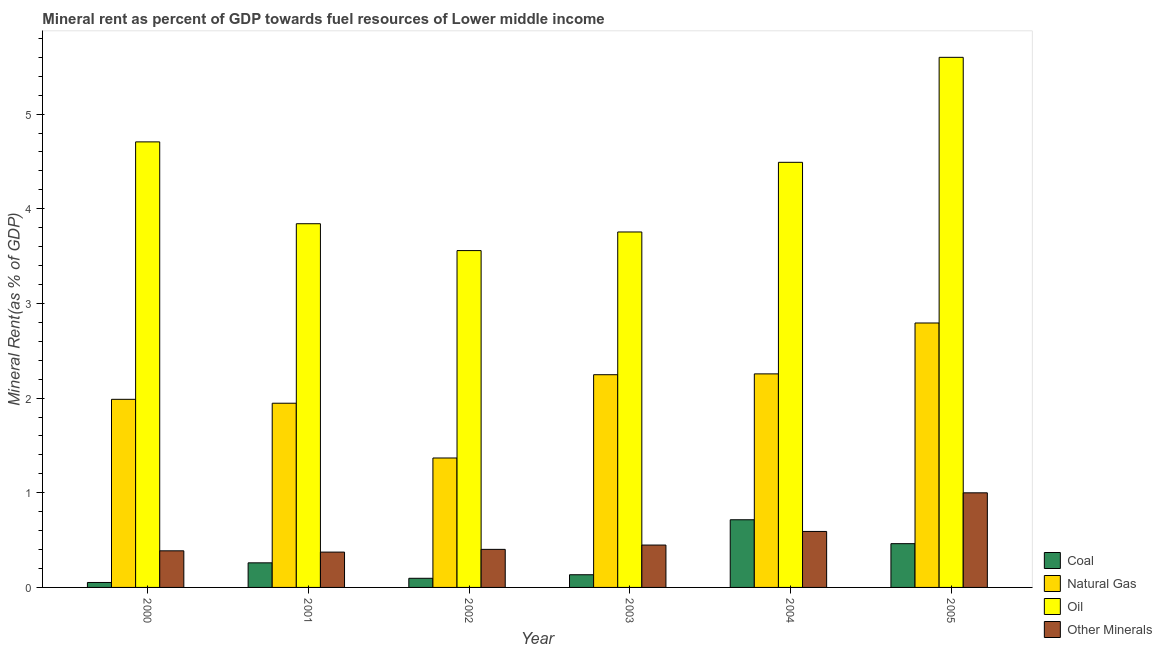Are the number of bars per tick equal to the number of legend labels?
Your answer should be compact. Yes. How many bars are there on the 5th tick from the left?
Ensure brevity in your answer.  4. How many bars are there on the 4th tick from the right?
Give a very brief answer. 4. What is the label of the 6th group of bars from the left?
Your response must be concise. 2005. In how many cases, is the number of bars for a given year not equal to the number of legend labels?
Make the answer very short. 0. What is the coal rent in 2001?
Make the answer very short. 0.26. Across all years, what is the maximum coal rent?
Your answer should be compact. 0.71. Across all years, what is the minimum  rent of other minerals?
Ensure brevity in your answer.  0.37. In which year was the coal rent maximum?
Ensure brevity in your answer.  2004. In which year was the coal rent minimum?
Your answer should be compact. 2000. What is the total  rent of other minerals in the graph?
Your response must be concise. 3.2. What is the difference between the  rent of other minerals in 2002 and that in 2004?
Provide a succinct answer. -0.19. What is the difference between the natural gas rent in 2005 and the oil rent in 2003?
Give a very brief answer. 0.55. What is the average natural gas rent per year?
Give a very brief answer. 2.1. In the year 2004, what is the difference between the natural gas rent and coal rent?
Give a very brief answer. 0. What is the ratio of the coal rent in 2000 to that in 2002?
Offer a terse response. 0.54. What is the difference between the highest and the second highest  rent of other minerals?
Make the answer very short. 0.41. What is the difference between the highest and the lowest natural gas rent?
Keep it short and to the point. 1.43. In how many years, is the coal rent greater than the average coal rent taken over all years?
Your response must be concise. 2. What does the 1st bar from the left in 2001 represents?
Offer a terse response. Coal. What does the 4th bar from the right in 2000 represents?
Keep it short and to the point. Coal. Are all the bars in the graph horizontal?
Provide a succinct answer. No. How many years are there in the graph?
Keep it short and to the point. 6. What is the difference between two consecutive major ticks on the Y-axis?
Your answer should be very brief. 1. Are the values on the major ticks of Y-axis written in scientific E-notation?
Offer a terse response. No. Does the graph contain any zero values?
Provide a short and direct response. No. How many legend labels are there?
Provide a short and direct response. 4. What is the title of the graph?
Your answer should be very brief. Mineral rent as percent of GDP towards fuel resources of Lower middle income. Does "UNTA" appear as one of the legend labels in the graph?
Provide a succinct answer. No. What is the label or title of the X-axis?
Make the answer very short. Year. What is the label or title of the Y-axis?
Provide a short and direct response. Mineral Rent(as % of GDP). What is the Mineral Rent(as % of GDP) of Coal in 2000?
Provide a short and direct response. 0.05. What is the Mineral Rent(as % of GDP) in Natural Gas in 2000?
Your answer should be compact. 1.99. What is the Mineral Rent(as % of GDP) of Oil in 2000?
Offer a very short reply. 4.71. What is the Mineral Rent(as % of GDP) in Other Minerals in 2000?
Make the answer very short. 0.39. What is the Mineral Rent(as % of GDP) of Coal in 2001?
Provide a succinct answer. 0.26. What is the Mineral Rent(as % of GDP) in Natural Gas in 2001?
Ensure brevity in your answer.  1.95. What is the Mineral Rent(as % of GDP) of Oil in 2001?
Offer a very short reply. 3.84. What is the Mineral Rent(as % of GDP) in Other Minerals in 2001?
Offer a terse response. 0.37. What is the Mineral Rent(as % of GDP) in Coal in 2002?
Your response must be concise. 0.1. What is the Mineral Rent(as % of GDP) in Natural Gas in 2002?
Provide a succinct answer. 1.37. What is the Mineral Rent(as % of GDP) of Oil in 2002?
Keep it short and to the point. 3.56. What is the Mineral Rent(as % of GDP) in Other Minerals in 2002?
Make the answer very short. 0.4. What is the Mineral Rent(as % of GDP) of Coal in 2003?
Give a very brief answer. 0.13. What is the Mineral Rent(as % of GDP) in Natural Gas in 2003?
Your answer should be compact. 2.25. What is the Mineral Rent(as % of GDP) of Oil in 2003?
Make the answer very short. 3.75. What is the Mineral Rent(as % of GDP) of Other Minerals in 2003?
Give a very brief answer. 0.45. What is the Mineral Rent(as % of GDP) of Coal in 2004?
Provide a short and direct response. 0.71. What is the Mineral Rent(as % of GDP) of Natural Gas in 2004?
Provide a short and direct response. 2.26. What is the Mineral Rent(as % of GDP) of Oil in 2004?
Your response must be concise. 4.49. What is the Mineral Rent(as % of GDP) in Other Minerals in 2004?
Keep it short and to the point. 0.59. What is the Mineral Rent(as % of GDP) in Coal in 2005?
Your answer should be compact. 0.46. What is the Mineral Rent(as % of GDP) of Natural Gas in 2005?
Give a very brief answer. 2.79. What is the Mineral Rent(as % of GDP) in Oil in 2005?
Your answer should be very brief. 5.6. What is the Mineral Rent(as % of GDP) in Other Minerals in 2005?
Give a very brief answer. 1. Across all years, what is the maximum Mineral Rent(as % of GDP) of Coal?
Your answer should be compact. 0.71. Across all years, what is the maximum Mineral Rent(as % of GDP) of Natural Gas?
Your response must be concise. 2.79. Across all years, what is the maximum Mineral Rent(as % of GDP) of Oil?
Your answer should be compact. 5.6. Across all years, what is the maximum Mineral Rent(as % of GDP) in Other Minerals?
Offer a very short reply. 1. Across all years, what is the minimum Mineral Rent(as % of GDP) of Coal?
Your answer should be compact. 0.05. Across all years, what is the minimum Mineral Rent(as % of GDP) in Natural Gas?
Make the answer very short. 1.37. Across all years, what is the minimum Mineral Rent(as % of GDP) in Oil?
Offer a very short reply. 3.56. Across all years, what is the minimum Mineral Rent(as % of GDP) of Other Minerals?
Your answer should be compact. 0.37. What is the total Mineral Rent(as % of GDP) of Coal in the graph?
Provide a succinct answer. 1.72. What is the total Mineral Rent(as % of GDP) in Natural Gas in the graph?
Provide a short and direct response. 12.6. What is the total Mineral Rent(as % of GDP) of Oil in the graph?
Make the answer very short. 25.95. What is the total Mineral Rent(as % of GDP) of Other Minerals in the graph?
Ensure brevity in your answer.  3.2. What is the difference between the Mineral Rent(as % of GDP) in Coal in 2000 and that in 2001?
Your answer should be very brief. -0.21. What is the difference between the Mineral Rent(as % of GDP) of Natural Gas in 2000 and that in 2001?
Your answer should be compact. 0.04. What is the difference between the Mineral Rent(as % of GDP) in Oil in 2000 and that in 2001?
Your answer should be compact. 0.86. What is the difference between the Mineral Rent(as % of GDP) in Other Minerals in 2000 and that in 2001?
Your answer should be compact. 0.01. What is the difference between the Mineral Rent(as % of GDP) in Coal in 2000 and that in 2002?
Keep it short and to the point. -0.04. What is the difference between the Mineral Rent(as % of GDP) of Natural Gas in 2000 and that in 2002?
Ensure brevity in your answer.  0.62. What is the difference between the Mineral Rent(as % of GDP) of Oil in 2000 and that in 2002?
Provide a succinct answer. 1.15. What is the difference between the Mineral Rent(as % of GDP) in Other Minerals in 2000 and that in 2002?
Give a very brief answer. -0.02. What is the difference between the Mineral Rent(as % of GDP) in Coal in 2000 and that in 2003?
Your response must be concise. -0.08. What is the difference between the Mineral Rent(as % of GDP) in Natural Gas in 2000 and that in 2003?
Your answer should be very brief. -0.26. What is the difference between the Mineral Rent(as % of GDP) in Oil in 2000 and that in 2003?
Keep it short and to the point. 0.95. What is the difference between the Mineral Rent(as % of GDP) in Other Minerals in 2000 and that in 2003?
Ensure brevity in your answer.  -0.06. What is the difference between the Mineral Rent(as % of GDP) of Coal in 2000 and that in 2004?
Keep it short and to the point. -0.66. What is the difference between the Mineral Rent(as % of GDP) in Natural Gas in 2000 and that in 2004?
Your response must be concise. -0.27. What is the difference between the Mineral Rent(as % of GDP) in Oil in 2000 and that in 2004?
Offer a terse response. 0.22. What is the difference between the Mineral Rent(as % of GDP) of Other Minerals in 2000 and that in 2004?
Your answer should be compact. -0.2. What is the difference between the Mineral Rent(as % of GDP) of Coal in 2000 and that in 2005?
Your answer should be very brief. -0.41. What is the difference between the Mineral Rent(as % of GDP) of Natural Gas in 2000 and that in 2005?
Give a very brief answer. -0.81. What is the difference between the Mineral Rent(as % of GDP) of Oil in 2000 and that in 2005?
Offer a very short reply. -0.89. What is the difference between the Mineral Rent(as % of GDP) in Other Minerals in 2000 and that in 2005?
Offer a very short reply. -0.61. What is the difference between the Mineral Rent(as % of GDP) of Coal in 2001 and that in 2002?
Ensure brevity in your answer.  0.16. What is the difference between the Mineral Rent(as % of GDP) in Natural Gas in 2001 and that in 2002?
Make the answer very short. 0.58. What is the difference between the Mineral Rent(as % of GDP) in Oil in 2001 and that in 2002?
Keep it short and to the point. 0.28. What is the difference between the Mineral Rent(as % of GDP) of Other Minerals in 2001 and that in 2002?
Keep it short and to the point. -0.03. What is the difference between the Mineral Rent(as % of GDP) of Coal in 2001 and that in 2003?
Provide a succinct answer. 0.13. What is the difference between the Mineral Rent(as % of GDP) of Natural Gas in 2001 and that in 2003?
Your answer should be very brief. -0.3. What is the difference between the Mineral Rent(as % of GDP) in Oil in 2001 and that in 2003?
Give a very brief answer. 0.09. What is the difference between the Mineral Rent(as % of GDP) in Other Minerals in 2001 and that in 2003?
Provide a succinct answer. -0.07. What is the difference between the Mineral Rent(as % of GDP) in Coal in 2001 and that in 2004?
Ensure brevity in your answer.  -0.46. What is the difference between the Mineral Rent(as % of GDP) in Natural Gas in 2001 and that in 2004?
Ensure brevity in your answer.  -0.31. What is the difference between the Mineral Rent(as % of GDP) of Oil in 2001 and that in 2004?
Your answer should be very brief. -0.65. What is the difference between the Mineral Rent(as % of GDP) of Other Minerals in 2001 and that in 2004?
Provide a short and direct response. -0.22. What is the difference between the Mineral Rent(as % of GDP) of Coal in 2001 and that in 2005?
Your answer should be very brief. -0.2. What is the difference between the Mineral Rent(as % of GDP) of Natural Gas in 2001 and that in 2005?
Provide a short and direct response. -0.85. What is the difference between the Mineral Rent(as % of GDP) in Oil in 2001 and that in 2005?
Provide a succinct answer. -1.76. What is the difference between the Mineral Rent(as % of GDP) of Other Minerals in 2001 and that in 2005?
Your answer should be compact. -0.63. What is the difference between the Mineral Rent(as % of GDP) of Coal in 2002 and that in 2003?
Provide a short and direct response. -0.04. What is the difference between the Mineral Rent(as % of GDP) in Natural Gas in 2002 and that in 2003?
Your answer should be compact. -0.88. What is the difference between the Mineral Rent(as % of GDP) in Oil in 2002 and that in 2003?
Ensure brevity in your answer.  -0.2. What is the difference between the Mineral Rent(as % of GDP) of Other Minerals in 2002 and that in 2003?
Offer a terse response. -0.05. What is the difference between the Mineral Rent(as % of GDP) of Coal in 2002 and that in 2004?
Provide a succinct answer. -0.62. What is the difference between the Mineral Rent(as % of GDP) in Natural Gas in 2002 and that in 2004?
Provide a succinct answer. -0.89. What is the difference between the Mineral Rent(as % of GDP) in Oil in 2002 and that in 2004?
Offer a terse response. -0.93. What is the difference between the Mineral Rent(as % of GDP) of Other Minerals in 2002 and that in 2004?
Make the answer very short. -0.19. What is the difference between the Mineral Rent(as % of GDP) of Coal in 2002 and that in 2005?
Offer a terse response. -0.37. What is the difference between the Mineral Rent(as % of GDP) in Natural Gas in 2002 and that in 2005?
Provide a short and direct response. -1.43. What is the difference between the Mineral Rent(as % of GDP) in Oil in 2002 and that in 2005?
Your answer should be very brief. -2.04. What is the difference between the Mineral Rent(as % of GDP) in Other Minerals in 2002 and that in 2005?
Keep it short and to the point. -0.6. What is the difference between the Mineral Rent(as % of GDP) of Coal in 2003 and that in 2004?
Provide a short and direct response. -0.58. What is the difference between the Mineral Rent(as % of GDP) of Natural Gas in 2003 and that in 2004?
Give a very brief answer. -0.01. What is the difference between the Mineral Rent(as % of GDP) in Oil in 2003 and that in 2004?
Keep it short and to the point. -0.74. What is the difference between the Mineral Rent(as % of GDP) in Other Minerals in 2003 and that in 2004?
Provide a short and direct response. -0.14. What is the difference between the Mineral Rent(as % of GDP) in Coal in 2003 and that in 2005?
Keep it short and to the point. -0.33. What is the difference between the Mineral Rent(as % of GDP) of Natural Gas in 2003 and that in 2005?
Keep it short and to the point. -0.55. What is the difference between the Mineral Rent(as % of GDP) in Oil in 2003 and that in 2005?
Ensure brevity in your answer.  -1.84. What is the difference between the Mineral Rent(as % of GDP) of Other Minerals in 2003 and that in 2005?
Keep it short and to the point. -0.55. What is the difference between the Mineral Rent(as % of GDP) of Coal in 2004 and that in 2005?
Your answer should be compact. 0.25. What is the difference between the Mineral Rent(as % of GDP) in Natural Gas in 2004 and that in 2005?
Your response must be concise. -0.54. What is the difference between the Mineral Rent(as % of GDP) in Oil in 2004 and that in 2005?
Provide a short and direct response. -1.11. What is the difference between the Mineral Rent(as % of GDP) of Other Minerals in 2004 and that in 2005?
Ensure brevity in your answer.  -0.41. What is the difference between the Mineral Rent(as % of GDP) of Coal in 2000 and the Mineral Rent(as % of GDP) of Natural Gas in 2001?
Offer a very short reply. -1.89. What is the difference between the Mineral Rent(as % of GDP) of Coal in 2000 and the Mineral Rent(as % of GDP) of Oil in 2001?
Your answer should be very brief. -3.79. What is the difference between the Mineral Rent(as % of GDP) of Coal in 2000 and the Mineral Rent(as % of GDP) of Other Minerals in 2001?
Keep it short and to the point. -0.32. What is the difference between the Mineral Rent(as % of GDP) in Natural Gas in 2000 and the Mineral Rent(as % of GDP) in Oil in 2001?
Give a very brief answer. -1.85. What is the difference between the Mineral Rent(as % of GDP) in Natural Gas in 2000 and the Mineral Rent(as % of GDP) in Other Minerals in 2001?
Make the answer very short. 1.61. What is the difference between the Mineral Rent(as % of GDP) of Oil in 2000 and the Mineral Rent(as % of GDP) of Other Minerals in 2001?
Make the answer very short. 4.33. What is the difference between the Mineral Rent(as % of GDP) in Coal in 2000 and the Mineral Rent(as % of GDP) in Natural Gas in 2002?
Provide a succinct answer. -1.31. What is the difference between the Mineral Rent(as % of GDP) in Coal in 2000 and the Mineral Rent(as % of GDP) in Oil in 2002?
Provide a succinct answer. -3.51. What is the difference between the Mineral Rent(as % of GDP) in Coal in 2000 and the Mineral Rent(as % of GDP) in Other Minerals in 2002?
Offer a very short reply. -0.35. What is the difference between the Mineral Rent(as % of GDP) in Natural Gas in 2000 and the Mineral Rent(as % of GDP) in Oil in 2002?
Keep it short and to the point. -1.57. What is the difference between the Mineral Rent(as % of GDP) in Natural Gas in 2000 and the Mineral Rent(as % of GDP) in Other Minerals in 2002?
Ensure brevity in your answer.  1.58. What is the difference between the Mineral Rent(as % of GDP) of Oil in 2000 and the Mineral Rent(as % of GDP) of Other Minerals in 2002?
Give a very brief answer. 4.3. What is the difference between the Mineral Rent(as % of GDP) in Coal in 2000 and the Mineral Rent(as % of GDP) in Natural Gas in 2003?
Ensure brevity in your answer.  -2.19. What is the difference between the Mineral Rent(as % of GDP) in Coal in 2000 and the Mineral Rent(as % of GDP) in Oil in 2003?
Offer a terse response. -3.7. What is the difference between the Mineral Rent(as % of GDP) of Coal in 2000 and the Mineral Rent(as % of GDP) of Other Minerals in 2003?
Make the answer very short. -0.4. What is the difference between the Mineral Rent(as % of GDP) of Natural Gas in 2000 and the Mineral Rent(as % of GDP) of Oil in 2003?
Offer a very short reply. -1.77. What is the difference between the Mineral Rent(as % of GDP) of Natural Gas in 2000 and the Mineral Rent(as % of GDP) of Other Minerals in 2003?
Make the answer very short. 1.54. What is the difference between the Mineral Rent(as % of GDP) in Oil in 2000 and the Mineral Rent(as % of GDP) in Other Minerals in 2003?
Give a very brief answer. 4.26. What is the difference between the Mineral Rent(as % of GDP) of Coal in 2000 and the Mineral Rent(as % of GDP) of Natural Gas in 2004?
Provide a short and direct response. -2.2. What is the difference between the Mineral Rent(as % of GDP) of Coal in 2000 and the Mineral Rent(as % of GDP) of Oil in 2004?
Offer a very short reply. -4.44. What is the difference between the Mineral Rent(as % of GDP) in Coal in 2000 and the Mineral Rent(as % of GDP) in Other Minerals in 2004?
Offer a terse response. -0.54. What is the difference between the Mineral Rent(as % of GDP) in Natural Gas in 2000 and the Mineral Rent(as % of GDP) in Oil in 2004?
Offer a very short reply. -2.5. What is the difference between the Mineral Rent(as % of GDP) of Natural Gas in 2000 and the Mineral Rent(as % of GDP) of Other Minerals in 2004?
Offer a terse response. 1.4. What is the difference between the Mineral Rent(as % of GDP) of Oil in 2000 and the Mineral Rent(as % of GDP) of Other Minerals in 2004?
Ensure brevity in your answer.  4.12. What is the difference between the Mineral Rent(as % of GDP) in Coal in 2000 and the Mineral Rent(as % of GDP) in Natural Gas in 2005?
Offer a very short reply. -2.74. What is the difference between the Mineral Rent(as % of GDP) in Coal in 2000 and the Mineral Rent(as % of GDP) in Oil in 2005?
Offer a terse response. -5.55. What is the difference between the Mineral Rent(as % of GDP) of Coal in 2000 and the Mineral Rent(as % of GDP) of Other Minerals in 2005?
Ensure brevity in your answer.  -0.95. What is the difference between the Mineral Rent(as % of GDP) of Natural Gas in 2000 and the Mineral Rent(as % of GDP) of Oil in 2005?
Your answer should be compact. -3.61. What is the difference between the Mineral Rent(as % of GDP) in Natural Gas in 2000 and the Mineral Rent(as % of GDP) in Other Minerals in 2005?
Your response must be concise. 0.99. What is the difference between the Mineral Rent(as % of GDP) in Oil in 2000 and the Mineral Rent(as % of GDP) in Other Minerals in 2005?
Provide a short and direct response. 3.71. What is the difference between the Mineral Rent(as % of GDP) of Coal in 2001 and the Mineral Rent(as % of GDP) of Natural Gas in 2002?
Your answer should be very brief. -1.11. What is the difference between the Mineral Rent(as % of GDP) in Coal in 2001 and the Mineral Rent(as % of GDP) in Oil in 2002?
Your response must be concise. -3.3. What is the difference between the Mineral Rent(as % of GDP) of Coal in 2001 and the Mineral Rent(as % of GDP) of Other Minerals in 2002?
Your answer should be compact. -0.14. What is the difference between the Mineral Rent(as % of GDP) of Natural Gas in 2001 and the Mineral Rent(as % of GDP) of Oil in 2002?
Ensure brevity in your answer.  -1.61. What is the difference between the Mineral Rent(as % of GDP) of Natural Gas in 2001 and the Mineral Rent(as % of GDP) of Other Minerals in 2002?
Your answer should be compact. 1.54. What is the difference between the Mineral Rent(as % of GDP) of Oil in 2001 and the Mineral Rent(as % of GDP) of Other Minerals in 2002?
Your answer should be compact. 3.44. What is the difference between the Mineral Rent(as % of GDP) of Coal in 2001 and the Mineral Rent(as % of GDP) of Natural Gas in 2003?
Your answer should be compact. -1.99. What is the difference between the Mineral Rent(as % of GDP) of Coal in 2001 and the Mineral Rent(as % of GDP) of Oil in 2003?
Provide a succinct answer. -3.5. What is the difference between the Mineral Rent(as % of GDP) of Coal in 2001 and the Mineral Rent(as % of GDP) of Other Minerals in 2003?
Your answer should be compact. -0.19. What is the difference between the Mineral Rent(as % of GDP) in Natural Gas in 2001 and the Mineral Rent(as % of GDP) in Oil in 2003?
Give a very brief answer. -1.81. What is the difference between the Mineral Rent(as % of GDP) of Natural Gas in 2001 and the Mineral Rent(as % of GDP) of Other Minerals in 2003?
Ensure brevity in your answer.  1.5. What is the difference between the Mineral Rent(as % of GDP) of Oil in 2001 and the Mineral Rent(as % of GDP) of Other Minerals in 2003?
Give a very brief answer. 3.39. What is the difference between the Mineral Rent(as % of GDP) in Coal in 2001 and the Mineral Rent(as % of GDP) in Natural Gas in 2004?
Your response must be concise. -2. What is the difference between the Mineral Rent(as % of GDP) of Coal in 2001 and the Mineral Rent(as % of GDP) of Oil in 2004?
Offer a terse response. -4.23. What is the difference between the Mineral Rent(as % of GDP) in Coal in 2001 and the Mineral Rent(as % of GDP) in Other Minerals in 2004?
Give a very brief answer. -0.33. What is the difference between the Mineral Rent(as % of GDP) in Natural Gas in 2001 and the Mineral Rent(as % of GDP) in Oil in 2004?
Ensure brevity in your answer.  -2.54. What is the difference between the Mineral Rent(as % of GDP) in Natural Gas in 2001 and the Mineral Rent(as % of GDP) in Other Minerals in 2004?
Give a very brief answer. 1.35. What is the difference between the Mineral Rent(as % of GDP) in Oil in 2001 and the Mineral Rent(as % of GDP) in Other Minerals in 2004?
Provide a succinct answer. 3.25. What is the difference between the Mineral Rent(as % of GDP) in Coal in 2001 and the Mineral Rent(as % of GDP) in Natural Gas in 2005?
Provide a succinct answer. -2.53. What is the difference between the Mineral Rent(as % of GDP) in Coal in 2001 and the Mineral Rent(as % of GDP) in Oil in 2005?
Provide a short and direct response. -5.34. What is the difference between the Mineral Rent(as % of GDP) in Coal in 2001 and the Mineral Rent(as % of GDP) in Other Minerals in 2005?
Offer a terse response. -0.74. What is the difference between the Mineral Rent(as % of GDP) in Natural Gas in 2001 and the Mineral Rent(as % of GDP) in Oil in 2005?
Your answer should be very brief. -3.65. What is the difference between the Mineral Rent(as % of GDP) in Natural Gas in 2001 and the Mineral Rent(as % of GDP) in Other Minerals in 2005?
Your answer should be very brief. 0.95. What is the difference between the Mineral Rent(as % of GDP) in Oil in 2001 and the Mineral Rent(as % of GDP) in Other Minerals in 2005?
Your response must be concise. 2.84. What is the difference between the Mineral Rent(as % of GDP) in Coal in 2002 and the Mineral Rent(as % of GDP) in Natural Gas in 2003?
Provide a short and direct response. -2.15. What is the difference between the Mineral Rent(as % of GDP) of Coal in 2002 and the Mineral Rent(as % of GDP) of Oil in 2003?
Your response must be concise. -3.66. What is the difference between the Mineral Rent(as % of GDP) of Coal in 2002 and the Mineral Rent(as % of GDP) of Other Minerals in 2003?
Provide a succinct answer. -0.35. What is the difference between the Mineral Rent(as % of GDP) in Natural Gas in 2002 and the Mineral Rent(as % of GDP) in Oil in 2003?
Offer a terse response. -2.39. What is the difference between the Mineral Rent(as % of GDP) of Natural Gas in 2002 and the Mineral Rent(as % of GDP) of Other Minerals in 2003?
Your answer should be compact. 0.92. What is the difference between the Mineral Rent(as % of GDP) in Oil in 2002 and the Mineral Rent(as % of GDP) in Other Minerals in 2003?
Your answer should be compact. 3.11. What is the difference between the Mineral Rent(as % of GDP) of Coal in 2002 and the Mineral Rent(as % of GDP) of Natural Gas in 2004?
Your answer should be very brief. -2.16. What is the difference between the Mineral Rent(as % of GDP) in Coal in 2002 and the Mineral Rent(as % of GDP) in Oil in 2004?
Keep it short and to the point. -4.39. What is the difference between the Mineral Rent(as % of GDP) in Coal in 2002 and the Mineral Rent(as % of GDP) in Other Minerals in 2004?
Provide a succinct answer. -0.49. What is the difference between the Mineral Rent(as % of GDP) of Natural Gas in 2002 and the Mineral Rent(as % of GDP) of Oil in 2004?
Your answer should be compact. -3.12. What is the difference between the Mineral Rent(as % of GDP) of Natural Gas in 2002 and the Mineral Rent(as % of GDP) of Other Minerals in 2004?
Give a very brief answer. 0.78. What is the difference between the Mineral Rent(as % of GDP) in Oil in 2002 and the Mineral Rent(as % of GDP) in Other Minerals in 2004?
Ensure brevity in your answer.  2.97. What is the difference between the Mineral Rent(as % of GDP) in Coal in 2002 and the Mineral Rent(as % of GDP) in Natural Gas in 2005?
Provide a succinct answer. -2.7. What is the difference between the Mineral Rent(as % of GDP) of Coal in 2002 and the Mineral Rent(as % of GDP) of Oil in 2005?
Give a very brief answer. -5.5. What is the difference between the Mineral Rent(as % of GDP) in Coal in 2002 and the Mineral Rent(as % of GDP) in Other Minerals in 2005?
Make the answer very short. -0.9. What is the difference between the Mineral Rent(as % of GDP) of Natural Gas in 2002 and the Mineral Rent(as % of GDP) of Oil in 2005?
Offer a terse response. -4.23. What is the difference between the Mineral Rent(as % of GDP) in Natural Gas in 2002 and the Mineral Rent(as % of GDP) in Other Minerals in 2005?
Offer a terse response. 0.37. What is the difference between the Mineral Rent(as % of GDP) in Oil in 2002 and the Mineral Rent(as % of GDP) in Other Minerals in 2005?
Make the answer very short. 2.56. What is the difference between the Mineral Rent(as % of GDP) in Coal in 2003 and the Mineral Rent(as % of GDP) in Natural Gas in 2004?
Make the answer very short. -2.12. What is the difference between the Mineral Rent(as % of GDP) in Coal in 2003 and the Mineral Rent(as % of GDP) in Oil in 2004?
Give a very brief answer. -4.36. What is the difference between the Mineral Rent(as % of GDP) in Coal in 2003 and the Mineral Rent(as % of GDP) in Other Minerals in 2004?
Offer a terse response. -0.46. What is the difference between the Mineral Rent(as % of GDP) of Natural Gas in 2003 and the Mineral Rent(as % of GDP) of Oil in 2004?
Offer a very short reply. -2.24. What is the difference between the Mineral Rent(as % of GDP) in Natural Gas in 2003 and the Mineral Rent(as % of GDP) in Other Minerals in 2004?
Provide a short and direct response. 1.66. What is the difference between the Mineral Rent(as % of GDP) of Oil in 2003 and the Mineral Rent(as % of GDP) of Other Minerals in 2004?
Your response must be concise. 3.16. What is the difference between the Mineral Rent(as % of GDP) in Coal in 2003 and the Mineral Rent(as % of GDP) in Natural Gas in 2005?
Make the answer very short. -2.66. What is the difference between the Mineral Rent(as % of GDP) in Coal in 2003 and the Mineral Rent(as % of GDP) in Oil in 2005?
Give a very brief answer. -5.47. What is the difference between the Mineral Rent(as % of GDP) in Coal in 2003 and the Mineral Rent(as % of GDP) in Other Minerals in 2005?
Your response must be concise. -0.87. What is the difference between the Mineral Rent(as % of GDP) in Natural Gas in 2003 and the Mineral Rent(as % of GDP) in Oil in 2005?
Make the answer very short. -3.35. What is the difference between the Mineral Rent(as % of GDP) in Natural Gas in 2003 and the Mineral Rent(as % of GDP) in Other Minerals in 2005?
Provide a short and direct response. 1.25. What is the difference between the Mineral Rent(as % of GDP) in Oil in 2003 and the Mineral Rent(as % of GDP) in Other Minerals in 2005?
Offer a very short reply. 2.76. What is the difference between the Mineral Rent(as % of GDP) of Coal in 2004 and the Mineral Rent(as % of GDP) of Natural Gas in 2005?
Give a very brief answer. -2.08. What is the difference between the Mineral Rent(as % of GDP) of Coal in 2004 and the Mineral Rent(as % of GDP) of Oil in 2005?
Ensure brevity in your answer.  -4.88. What is the difference between the Mineral Rent(as % of GDP) in Coal in 2004 and the Mineral Rent(as % of GDP) in Other Minerals in 2005?
Offer a terse response. -0.28. What is the difference between the Mineral Rent(as % of GDP) in Natural Gas in 2004 and the Mineral Rent(as % of GDP) in Oil in 2005?
Keep it short and to the point. -3.34. What is the difference between the Mineral Rent(as % of GDP) in Natural Gas in 2004 and the Mineral Rent(as % of GDP) in Other Minerals in 2005?
Make the answer very short. 1.26. What is the difference between the Mineral Rent(as % of GDP) in Oil in 2004 and the Mineral Rent(as % of GDP) in Other Minerals in 2005?
Your response must be concise. 3.49. What is the average Mineral Rent(as % of GDP) in Coal per year?
Give a very brief answer. 0.29. What is the average Mineral Rent(as % of GDP) of Natural Gas per year?
Provide a succinct answer. 2.1. What is the average Mineral Rent(as % of GDP) of Oil per year?
Your response must be concise. 4.33. What is the average Mineral Rent(as % of GDP) of Other Minerals per year?
Ensure brevity in your answer.  0.53. In the year 2000, what is the difference between the Mineral Rent(as % of GDP) in Coal and Mineral Rent(as % of GDP) in Natural Gas?
Provide a succinct answer. -1.93. In the year 2000, what is the difference between the Mineral Rent(as % of GDP) in Coal and Mineral Rent(as % of GDP) in Oil?
Provide a short and direct response. -4.65. In the year 2000, what is the difference between the Mineral Rent(as % of GDP) in Coal and Mineral Rent(as % of GDP) in Other Minerals?
Ensure brevity in your answer.  -0.33. In the year 2000, what is the difference between the Mineral Rent(as % of GDP) of Natural Gas and Mineral Rent(as % of GDP) of Oil?
Give a very brief answer. -2.72. In the year 2000, what is the difference between the Mineral Rent(as % of GDP) in Natural Gas and Mineral Rent(as % of GDP) in Other Minerals?
Give a very brief answer. 1.6. In the year 2000, what is the difference between the Mineral Rent(as % of GDP) of Oil and Mineral Rent(as % of GDP) of Other Minerals?
Offer a terse response. 4.32. In the year 2001, what is the difference between the Mineral Rent(as % of GDP) of Coal and Mineral Rent(as % of GDP) of Natural Gas?
Give a very brief answer. -1.69. In the year 2001, what is the difference between the Mineral Rent(as % of GDP) of Coal and Mineral Rent(as % of GDP) of Oil?
Give a very brief answer. -3.58. In the year 2001, what is the difference between the Mineral Rent(as % of GDP) of Coal and Mineral Rent(as % of GDP) of Other Minerals?
Give a very brief answer. -0.11. In the year 2001, what is the difference between the Mineral Rent(as % of GDP) of Natural Gas and Mineral Rent(as % of GDP) of Oil?
Give a very brief answer. -1.9. In the year 2001, what is the difference between the Mineral Rent(as % of GDP) in Natural Gas and Mineral Rent(as % of GDP) in Other Minerals?
Provide a short and direct response. 1.57. In the year 2001, what is the difference between the Mineral Rent(as % of GDP) in Oil and Mineral Rent(as % of GDP) in Other Minerals?
Provide a short and direct response. 3.47. In the year 2002, what is the difference between the Mineral Rent(as % of GDP) of Coal and Mineral Rent(as % of GDP) of Natural Gas?
Your answer should be compact. -1.27. In the year 2002, what is the difference between the Mineral Rent(as % of GDP) of Coal and Mineral Rent(as % of GDP) of Oil?
Provide a succinct answer. -3.46. In the year 2002, what is the difference between the Mineral Rent(as % of GDP) of Coal and Mineral Rent(as % of GDP) of Other Minerals?
Offer a very short reply. -0.31. In the year 2002, what is the difference between the Mineral Rent(as % of GDP) of Natural Gas and Mineral Rent(as % of GDP) of Oil?
Your response must be concise. -2.19. In the year 2002, what is the difference between the Mineral Rent(as % of GDP) in Natural Gas and Mineral Rent(as % of GDP) in Other Minerals?
Offer a very short reply. 0.97. In the year 2002, what is the difference between the Mineral Rent(as % of GDP) of Oil and Mineral Rent(as % of GDP) of Other Minerals?
Give a very brief answer. 3.16. In the year 2003, what is the difference between the Mineral Rent(as % of GDP) in Coal and Mineral Rent(as % of GDP) in Natural Gas?
Your answer should be compact. -2.11. In the year 2003, what is the difference between the Mineral Rent(as % of GDP) of Coal and Mineral Rent(as % of GDP) of Oil?
Your response must be concise. -3.62. In the year 2003, what is the difference between the Mineral Rent(as % of GDP) in Coal and Mineral Rent(as % of GDP) in Other Minerals?
Your answer should be compact. -0.31. In the year 2003, what is the difference between the Mineral Rent(as % of GDP) of Natural Gas and Mineral Rent(as % of GDP) of Oil?
Give a very brief answer. -1.51. In the year 2003, what is the difference between the Mineral Rent(as % of GDP) of Natural Gas and Mineral Rent(as % of GDP) of Other Minerals?
Make the answer very short. 1.8. In the year 2003, what is the difference between the Mineral Rent(as % of GDP) in Oil and Mineral Rent(as % of GDP) in Other Minerals?
Ensure brevity in your answer.  3.31. In the year 2004, what is the difference between the Mineral Rent(as % of GDP) of Coal and Mineral Rent(as % of GDP) of Natural Gas?
Your answer should be compact. -1.54. In the year 2004, what is the difference between the Mineral Rent(as % of GDP) of Coal and Mineral Rent(as % of GDP) of Oil?
Your answer should be very brief. -3.78. In the year 2004, what is the difference between the Mineral Rent(as % of GDP) in Coal and Mineral Rent(as % of GDP) in Other Minerals?
Make the answer very short. 0.12. In the year 2004, what is the difference between the Mineral Rent(as % of GDP) in Natural Gas and Mineral Rent(as % of GDP) in Oil?
Make the answer very short. -2.23. In the year 2004, what is the difference between the Mineral Rent(as % of GDP) in Natural Gas and Mineral Rent(as % of GDP) in Other Minerals?
Keep it short and to the point. 1.66. In the year 2004, what is the difference between the Mineral Rent(as % of GDP) in Oil and Mineral Rent(as % of GDP) in Other Minerals?
Give a very brief answer. 3.9. In the year 2005, what is the difference between the Mineral Rent(as % of GDP) in Coal and Mineral Rent(as % of GDP) in Natural Gas?
Offer a terse response. -2.33. In the year 2005, what is the difference between the Mineral Rent(as % of GDP) in Coal and Mineral Rent(as % of GDP) in Oil?
Offer a very short reply. -5.14. In the year 2005, what is the difference between the Mineral Rent(as % of GDP) in Coal and Mineral Rent(as % of GDP) in Other Minerals?
Provide a short and direct response. -0.54. In the year 2005, what is the difference between the Mineral Rent(as % of GDP) of Natural Gas and Mineral Rent(as % of GDP) of Oil?
Offer a terse response. -2.81. In the year 2005, what is the difference between the Mineral Rent(as % of GDP) of Natural Gas and Mineral Rent(as % of GDP) of Other Minerals?
Offer a terse response. 1.79. In the year 2005, what is the difference between the Mineral Rent(as % of GDP) in Oil and Mineral Rent(as % of GDP) in Other Minerals?
Ensure brevity in your answer.  4.6. What is the ratio of the Mineral Rent(as % of GDP) in Coal in 2000 to that in 2001?
Offer a very short reply. 0.2. What is the ratio of the Mineral Rent(as % of GDP) of Natural Gas in 2000 to that in 2001?
Keep it short and to the point. 1.02. What is the ratio of the Mineral Rent(as % of GDP) in Oil in 2000 to that in 2001?
Keep it short and to the point. 1.23. What is the ratio of the Mineral Rent(as % of GDP) of Other Minerals in 2000 to that in 2001?
Offer a terse response. 1.04. What is the ratio of the Mineral Rent(as % of GDP) of Coal in 2000 to that in 2002?
Your answer should be compact. 0.54. What is the ratio of the Mineral Rent(as % of GDP) of Natural Gas in 2000 to that in 2002?
Make the answer very short. 1.45. What is the ratio of the Mineral Rent(as % of GDP) of Oil in 2000 to that in 2002?
Give a very brief answer. 1.32. What is the ratio of the Mineral Rent(as % of GDP) in Other Minerals in 2000 to that in 2002?
Your response must be concise. 0.96. What is the ratio of the Mineral Rent(as % of GDP) in Coal in 2000 to that in 2003?
Provide a short and direct response. 0.39. What is the ratio of the Mineral Rent(as % of GDP) of Natural Gas in 2000 to that in 2003?
Offer a very short reply. 0.88. What is the ratio of the Mineral Rent(as % of GDP) of Oil in 2000 to that in 2003?
Your answer should be compact. 1.25. What is the ratio of the Mineral Rent(as % of GDP) in Other Minerals in 2000 to that in 2003?
Give a very brief answer. 0.86. What is the ratio of the Mineral Rent(as % of GDP) in Coal in 2000 to that in 2004?
Offer a very short reply. 0.07. What is the ratio of the Mineral Rent(as % of GDP) of Natural Gas in 2000 to that in 2004?
Ensure brevity in your answer.  0.88. What is the ratio of the Mineral Rent(as % of GDP) in Oil in 2000 to that in 2004?
Offer a terse response. 1.05. What is the ratio of the Mineral Rent(as % of GDP) of Other Minerals in 2000 to that in 2004?
Ensure brevity in your answer.  0.65. What is the ratio of the Mineral Rent(as % of GDP) in Coal in 2000 to that in 2005?
Provide a short and direct response. 0.11. What is the ratio of the Mineral Rent(as % of GDP) in Natural Gas in 2000 to that in 2005?
Your answer should be very brief. 0.71. What is the ratio of the Mineral Rent(as % of GDP) in Oil in 2000 to that in 2005?
Your answer should be very brief. 0.84. What is the ratio of the Mineral Rent(as % of GDP) in Other Minerals in 2000 to that in 2005?
Provide a succinct answer. 0.39. What is the ratio of the Mineral Rent(as % of GDP) of Coal in 2001 to that in 2002?
Ensure brevity in your answer.  2.69. What is the ratio of the Mineral Rent(as % of GDP) in Natural Gas in 2001 to that in 2002?
Give a very brief answer. 1.42. What is the ratio of the Mineral Rent(as % of GDP) in Oil in 2001 to that in 2002?
Provide a succinct answer. 1.08. What is the ratio of the Mineral Rent(as % of GDP) in Other Minerals in 2001 to that in 2002?
Ensure brevity in your answer.  0.93. What is the ratio of the Mineral Rent(as % of GDP) in Coal in 2001 to that in 2003?
Offer a terse response. 1.94. What is the ratio of the Mineral Rent(as % of GDP) of Natural Gas in 2001 to that in 2003?
Offer a terse response. 0.87. What is the ratio of the Mineral Rent(as % of GDP) of Oil in 2001 to that in 2003?
Offer a terse response. 1.02. What is the ratio of the Mineral Rent(as % of GDP) of Other Minerals in 2001 to that in 2003?
Provide a short and direct response. 0.83. What is the ratio of the Mineral Rent(as % of GDP) of Coal in 2001 to that in 2004?
Your answer should be very brief. 0.36. What is the ratio of the Mineral Rent(as % of GDP) in Natural Gas in 2001 to that in 2004?
Provide a succinct answer. 0.86. What is the ratio of the Mineral Rent(as % of GDP) of Oil in 2001 to that in 2004?
Offer a terse response. 0.86. What is the ratio of the Mineral Rent(as % of GDP) in Other Minerals in 2001 to that in 2004?
Provide a succinct answer. 0.63. What is the ratio of the Mineral Rent(as % of GDP) in Coal in 2001 to that in 2005?
Your answer should be compact. 0.56. What is the ratio of the Mineral Rent(as % of GDP) of Natural Gas in 2001 to that in 2005?
Keep it short and to the point. 0.7. What is the ratio of the Mineral Rent(as % of GDP) of Oil in 2001 to that in 2005?
Give a very brief answer. 0.69. What is the ratio of the Mineral Rent(as % of GDP) of Other Minerals in 2001 to that in 2005?
Keep it short and to the point. 0.37. What is the ratio of the Mineral Rent(as % of GDP) in Coal in 2002 to that in 2003?
Give a very brief answer. 0.72. What is the ratio of the Mineral Rent(as % of GDP) of Natural Gas in 2002 to that in 2003?
Your answer should be very brief. 0.61. What is the ratio of the Mineral Rent(as % of GDP) in Oil in 2002 to that in 2003?
Offer a terse response. 0.95. What is the ratio of the Mineral Rent(as % of GDP) of Other Minerals in 2002 to that in 2003?
Make the answer very short. 0.9. What is the ratio of the Mineral Rent(as % of GDP) in Coal in 2002 to that in 2004?
Make the answer very short. 0.14. What is the ratio of the Mineral Rent(as % of GDP) in Natural Gas in 2002 to that in 2004?
Keep it short and to the point. 0.61. What is the ratio of the Mineral Rent(as % of GDP) in Oil in 2002 to that in 2004?
Keep it short and to the point. 0.79. What is the ratio of the Mineral Rent(as % of GDP) in Other Minerals in 2002 to that in 2004?
Offer a very short reply. 0.68. What is the ratio of the Mineral Rent(as % of GDP) in Coal in 2002 to that in 2005?
Your answer should be compact. 0.21. What is the ratio of the Mineral Rent(as % of GDP) in Natural Gas in 2002 to that in 2005?
Provide a short and direct response. 0.49. What is the ratio of the Mineral Rent(as % of GDP) in Oil in 2002 to that in 2005?
Give a very brief answer. 0.64. What is the ratio of the Mineral Rent(as % of GDP) of Other Minerals in 2002 to that in 2005?
Offer a very short reply. 0.4. What is the ratio of the Mineral Rent(as % of GDP) in Coal in 2003 to that in 2004?
Offer a terse response. 0.19. What is the ratio of the Mineral Rent(as % of GDP) of Oil in 2003 to that in 2004?
Give a very brief answer. 0.84. What is the ratio of the Mineral Rent(as % of GDP) of Other Minerals in 2003 to that in 2004?
Provide a short and direct response. 0.76. What is the ratio of the Mineral Rent(as % of GDP) of Coal in 2003 to that in 2005?
Ensure brevity in your answer.  0.29. What is the ratio of the Mineral Rent(as % of GDP) in Natural Gas in 2003 to that in 2005?
Make the answer very short. 0.8. What is the ratio of the Mineral Rent(as % of GDP) of Oil in 2003 to that in 2005?
Make the answer very short. 0.67. What is the ratio of the Mineral Rent(as % of GDP) in Other Minerals in 2003 to that in 2005?
Provide a succinct answer. 0.45. What is the ratio of the Mineral Rent(as % of GDP) in Coal in 2004 to that in 2005?
Provide a short and direct response. 1.55. What is the ratio of the Mineral Rent(as % of GDP) in Natural Gas in 2004 to that in 2005?
Offer a very short reply. 0.81. What is the ratio of the Mineral Rent(as % of GDP) of Oil in 2004 to that in 2005?
Give a very brief answer. 0.8. What is the ratio of the Mineral Rent(as % of GDP) in Other Minerals in 2004 to that in 2005?
Offer a terse response. 0.59. What is the difference between the highest and the second highest Mineral Rent(as % of GDP) of Coal?
Provide a succinct answer. 0.25. What is the difference between the highest and the second highest Mineral Rent(as % of GDP) in Natural Gas?
Your response must be concise. 0.54. What is the difference between the highest and the second highest Mineral Rent(as % of GDP) in Oil?
Offer a very short reply. 0.89. What is the difference between the highest and the second highest Mineral Rent(as % of GDP) in Other Minerals?
Your response must be concise. 0.41. What is the difference between the highest and the lowest Mineral Rent(as % of GDP) of Coal?
Provide a succinct answer. 0.66. What is the difference between the highest and the lowest Mineral Rent(as % of GDP) in Natural Gas?
Make the answer very short. 1.43. What is the difference between the highest and the lowest Mineral Rent(as % of GDP) in Oil?
Your answer should be compact. 2.04. What is the difference between the highest and the lowest Mineral Rent(as % of GDP) in Other Minerals?
Your answer should be very brief. 0.63. 